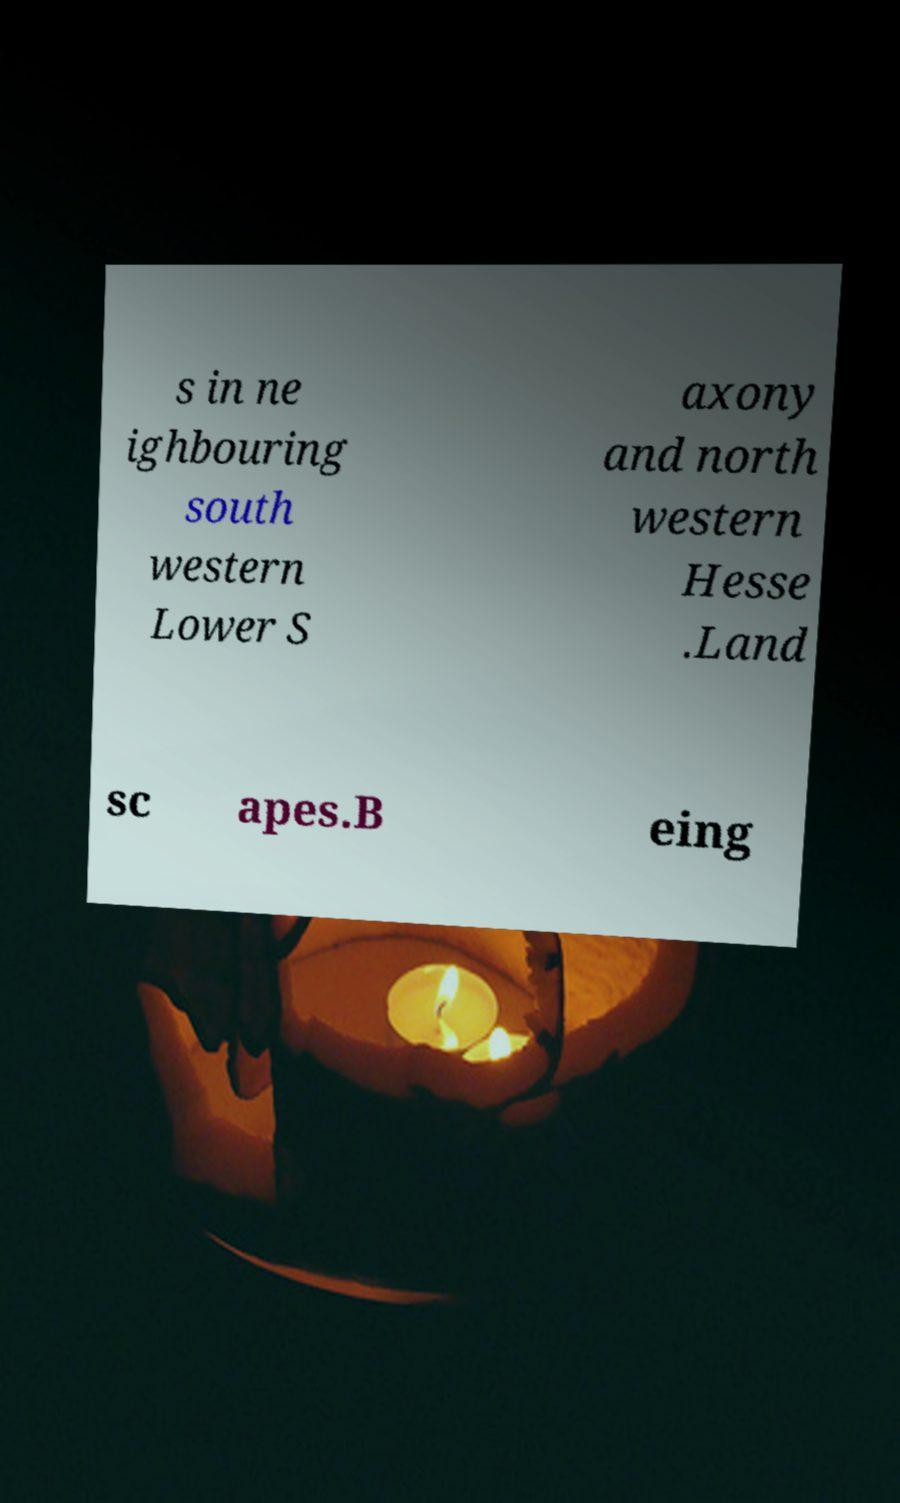For documentation purposes, I need the text within this image transcribed. Could you provide that? s in ne ighbouring south western Lower S axony and north western Hesse .Land sc apes.B eing 